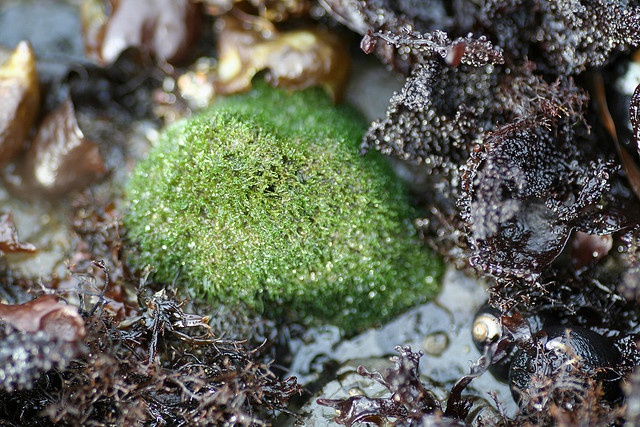Describe the objects in this image and their specific colors. I can see a broccoli in gray, olive, darkgreen, and green tones in this image. 